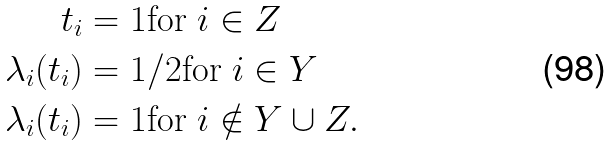Convert formula to latex. <formula><loc_0><loc_0><loc_500><loc_500>t _ { i } & = 1 \text {for } i \in Z \\ \lambda _ { i } ( t _ { i } ) & = 1 / 2 \text {for } i \in Y \\ \lambda _ { i } ( t _ { i } ) & = 1 \text {for } i \notin Y \cup Z .</formula> 